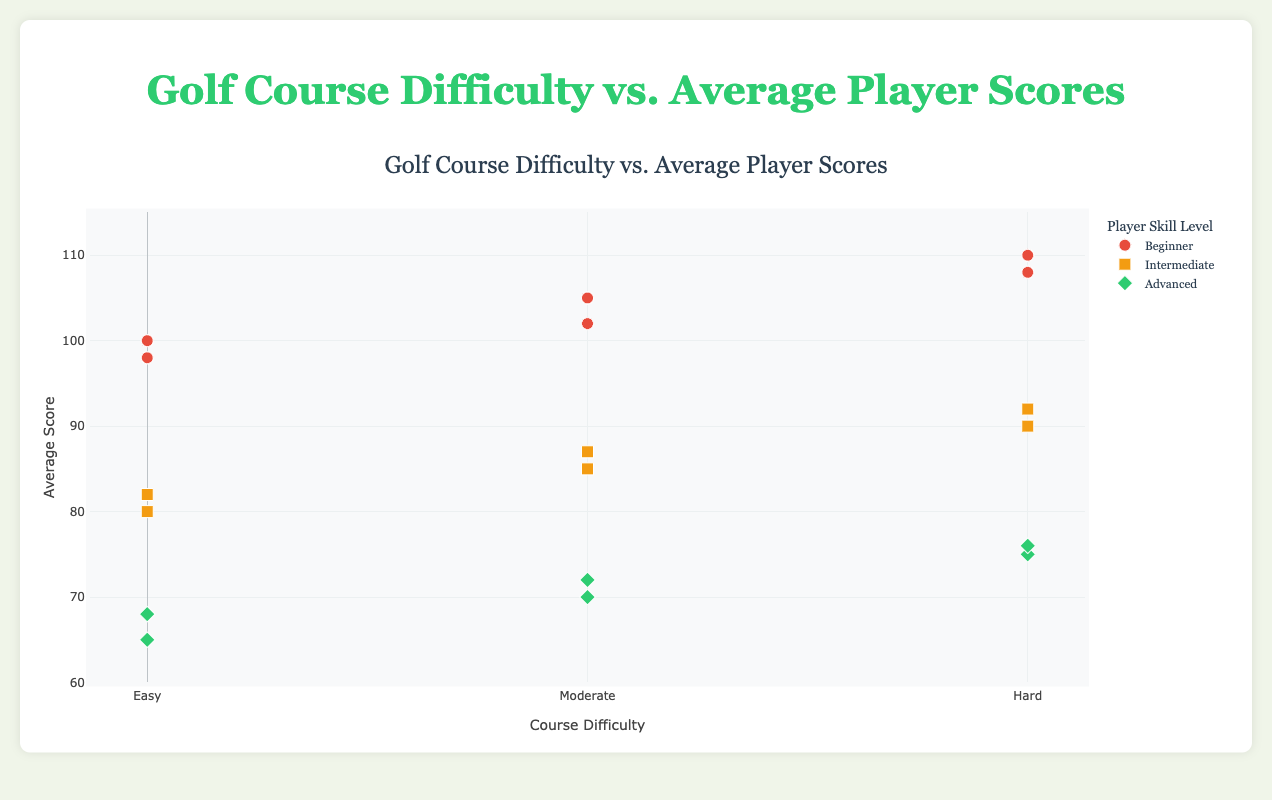What is the title of the figure? The title is displayed at the top center of the chart. It states "Golf Course Difficulty vs. Average Player Scores."
Answer: Golf Course Difficulty vs. Average Player Scores What range is used for the average score axis? The y-axis is labeled as 'Average Score,' and its range spans from 60 to 115.
Answer: 60 to 115 Which skill level has the lowest average score on Easy courses? To determine this, look at the scores for the 'Easy' difficulty level and locate the lowest point, which belongs to the 'Advanced' skill group with a score of 65.
Answer: Advanced How do average scores of Intermediate players compare between Moderate and Hard courses? Compare the y-axis values marked for the 'Intermediate' group for both 'Moderate' and 'Hard' difficulty levels. For 'Moderate,' scores are 85 and 87, while for 'Hard,' they are 90 and 92. Hence, Hard courses generally have higher average scores for Intermediate players.
Answer: Higher on Hard courses How many data points are there for the 'Beginner' skill level? Summarize the occurrences of 'Beginner' across all difficulty levels. Beginners appear 6 times (2 points each for Easy, Moderate, and Hard difficulties).
Answer: 6 What differences do you see between Easy and Hard courses for Advanced players? Compare the y-axis values for 'Advanced' between 'Easy' (scores are 65 and 68), and 'Hard' (scores are 75 and 76). This demonstrates that Advanced players generally have higher average scores on Hard courses than Easy ones.
Answer: Higher scores on Hard Which course and skill level combination has the highest average score? Examine the highest point on the y-axis across all data points. The highest average score is 110, observed in 'Pebble Beach Golf Links' for 'Beginner' skill level.
Answer: Pebble Beach Golf Links for Beginner On which course do Intermediate players have the lowest average score? Filter through the data points of Intermediate players across the different courses. 'Pinehurst No. 2' has the lowest Intermediate score at 82.
Answer: Pinehurst No. 2 What is the difference in average scores for Intermediate players between Pinehurst No. 2 and Torrey Pines? Look at the y-axis scores for Intermediate players on both courses: Pinehurst No. 2 has 82, while Torrey Pines scores 85. The difference is 85 - 82 = 3.
Answer: 3 